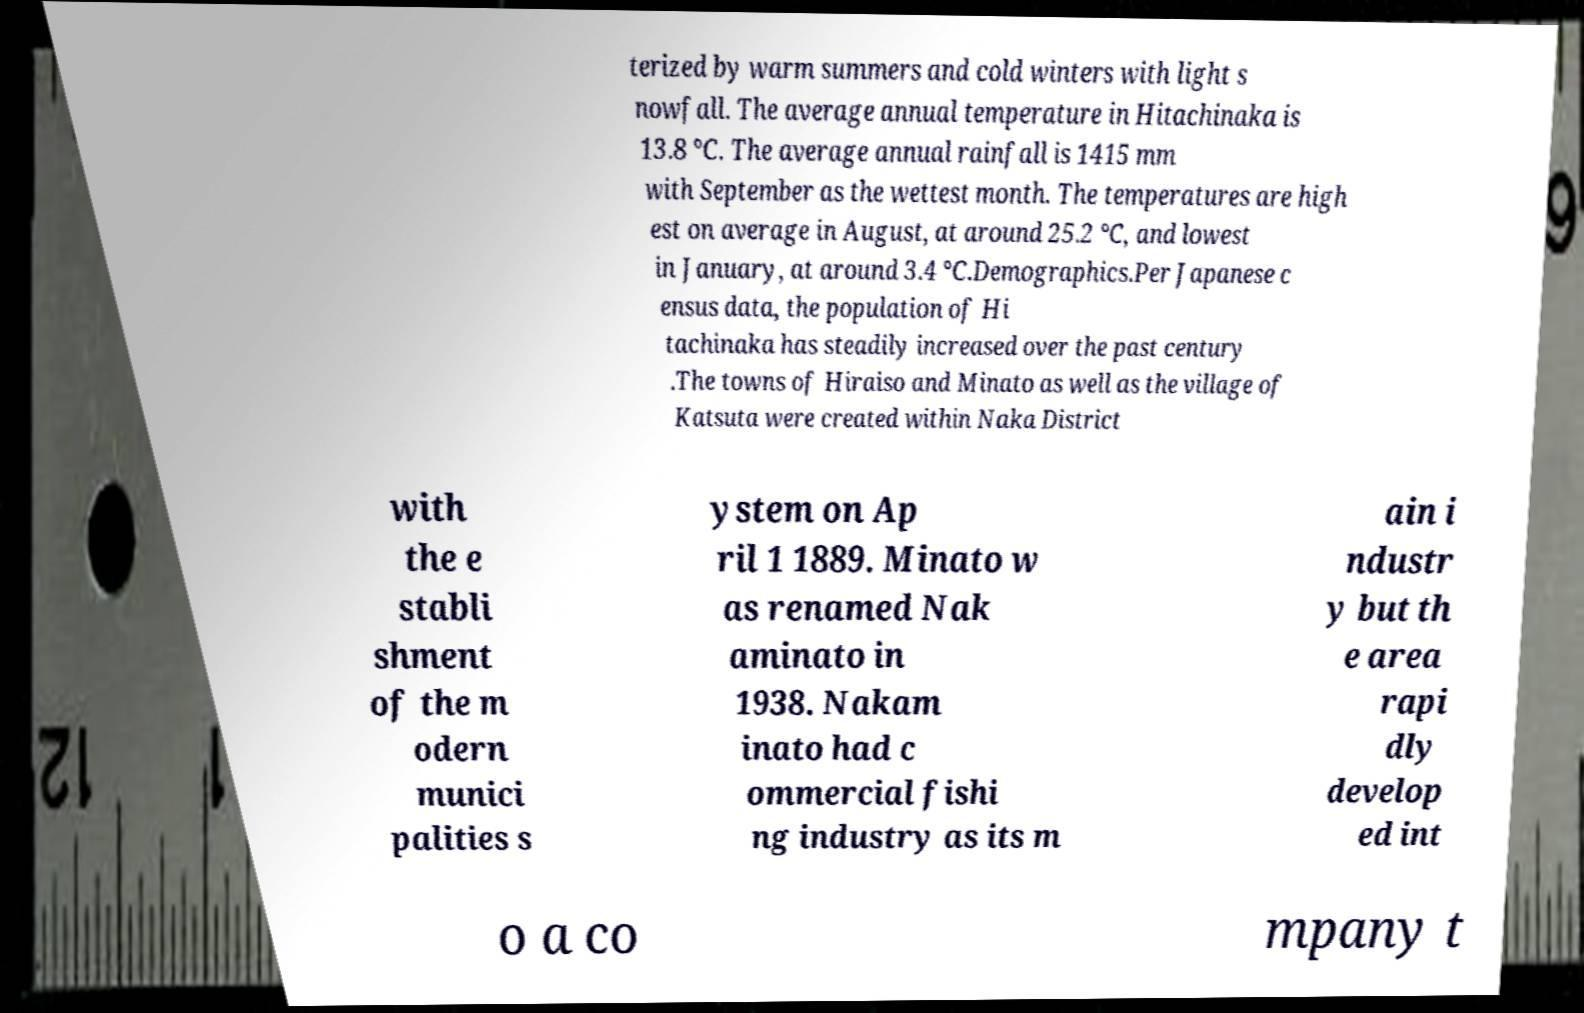For documentation purposes, I need the text within this image transcribed. Could you provide that? terized by warm summers and cold winters with light s nowfall. The average annual temperature in Hitachinaka is 13.8 °C. The average annual rainfall is 1415 mm with September as the wettest month. The temperatures are high est on average in August, at around 25.2 °C, and lowest in January, at around 3.4 °C.Demographics.Per Japanese c ensus data, the population of Hi tachinaka has steadily increased over the past century .The towns of Hiraiso and Minato as well as the village of Katsuta were created within Naka District with the e stabli shment of the m odern munici palities s ystem on Ap ril 1 1889. Minato w as renamed Nak aminato in 1938. Nakam inato had c ommercial fishi ng industry as its m ain i ndustr y but th e area rapi dly develop ed int o a co mpany t 